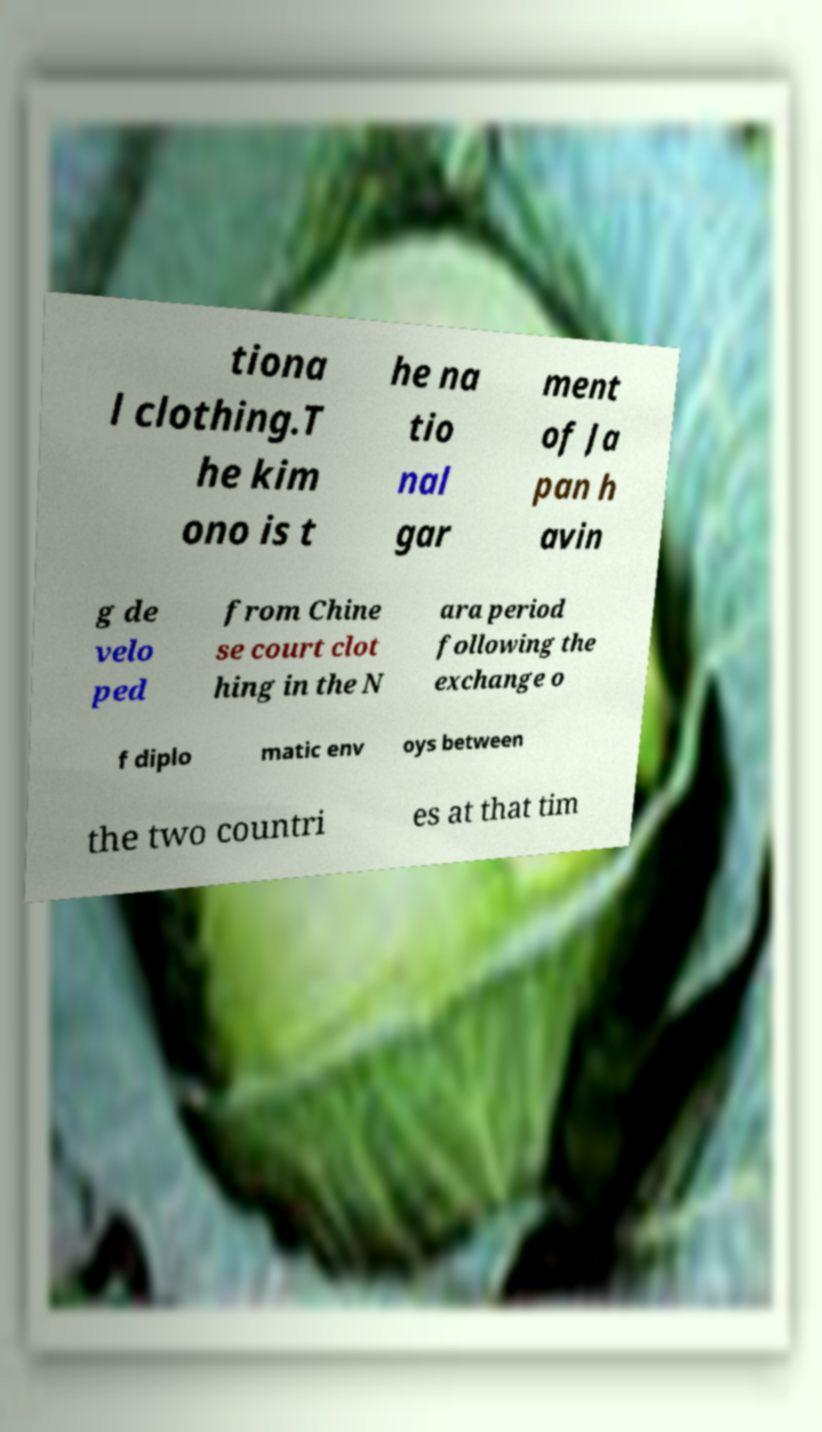I need the written content from this picture converted into text. Can you do that? tiona l clothing.T he kim ono is t he na tio nal gar ment of Ja pan h avin g de velo ped from Chine se court clot hing in the N ara period following the exchange o f diplo matic env oys between the two countri es at that tim 